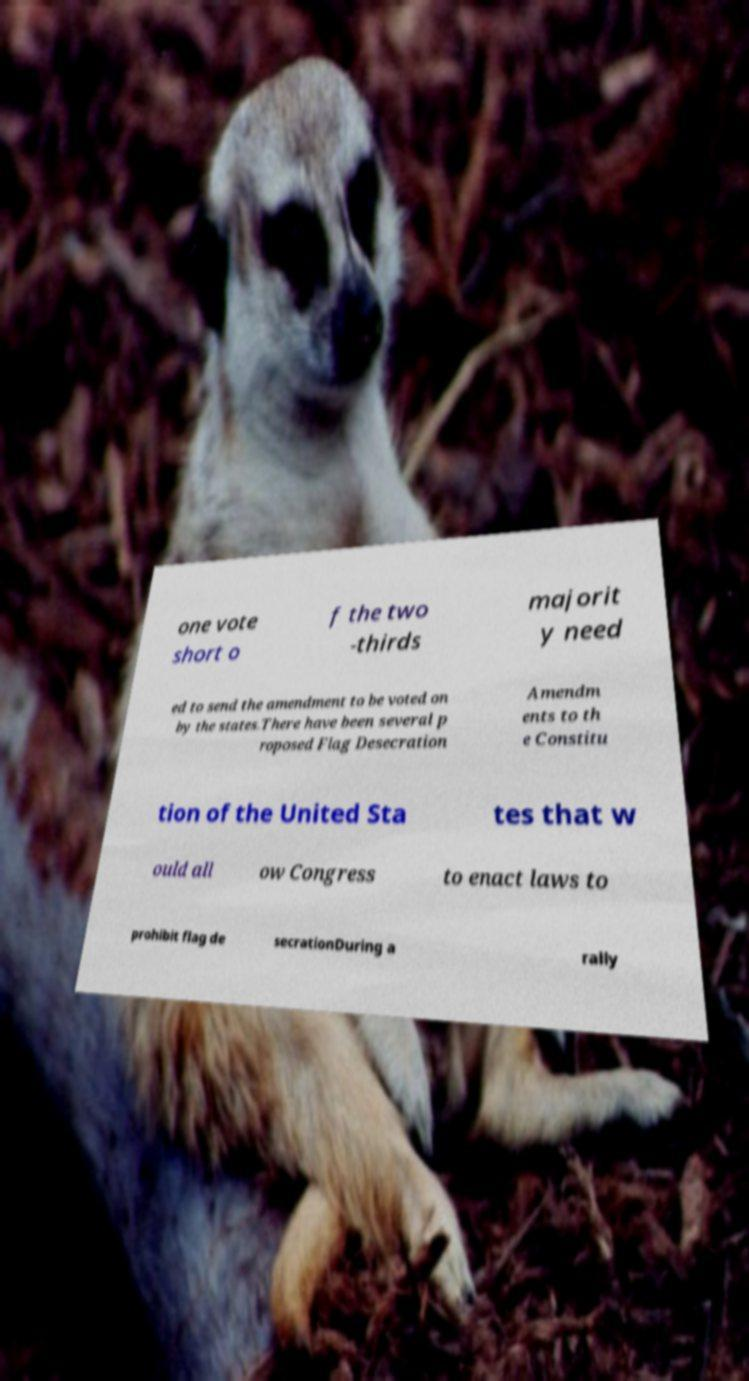Could you assist in decoding the text presented in this image and type it out clearly? one vote short o f the two -thirds majorit y need ed to send the amendment to be voted on by the states.There have been several p roposed Flag Desecration Amendm ents to th e Constitu tion of the United Sta tes that w ould all ow Congress to enact laws to prohibit flag de secrationDuring a rally 